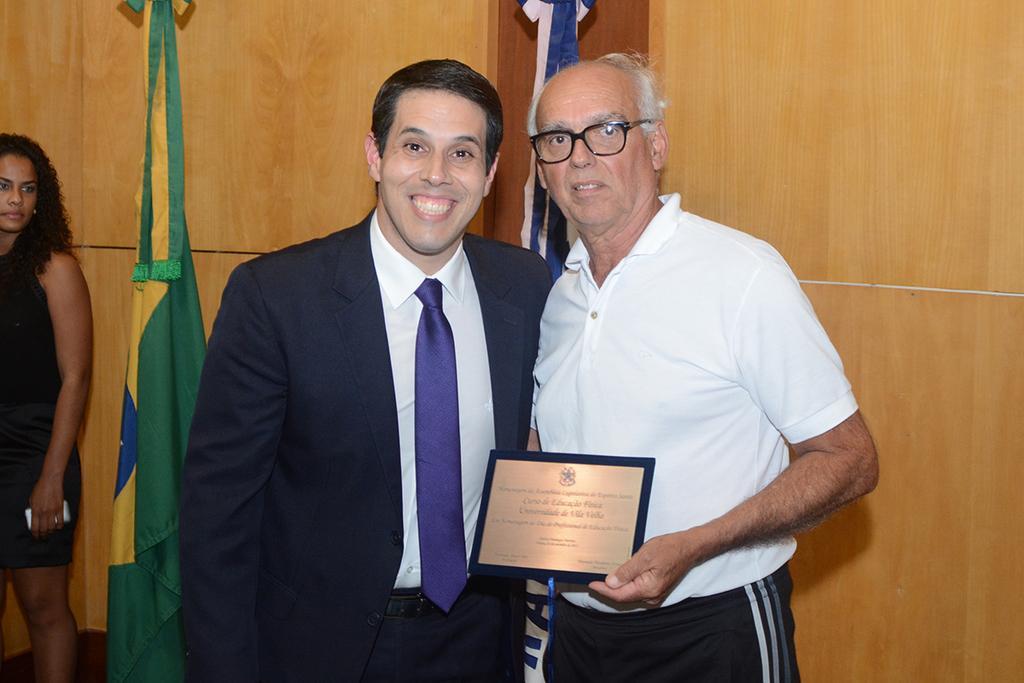Describe this image in one or two sentences. In this picture we can see two men standing in the front, a man on the right side is holding an award, on the left side there is a woman standing, in the background there are two flags, a man on the left side wore a suit. 